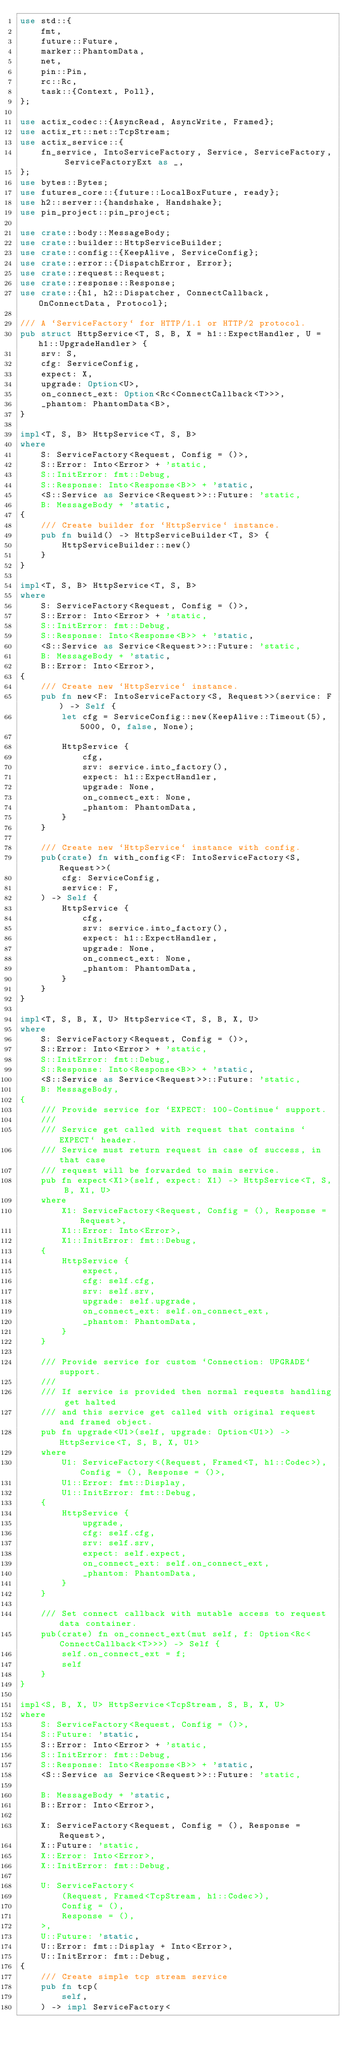Convert code to text. <code><loc_0><loc_0><loc_500><loc_500><_Rust_>use std::{
    fmt,
    future::Future,
    marker::PhantomData,
    net,
    pin::Pin,
    rc::Rc,
    task::{Context, Poll},
};

use actix_codec::{AsyncRead, AsyncWrite, Framed};
use actix_rt::net::TcpStream;
use actix_service::{
    fn_service, IntoServiceFactory, Service, ServiceFactory, ServiceFactoryExt as _,
};
use bytes::Bytes;
use futures_core::{future::LocalBoxFuture, ready};
use h2::server::{handshake, Handshake};
use pin_project::pin_project;

use crate::body::MessageBody;
use crate::builder::HttpServiceBuilder;
use crate::config::{KeepAlive, ServiceConfig};
use crate::error::{DispatchError, Error};
use crate::request::Request;
use crate::response::Response;
use crate::{h1, h2::Dispatcher, ConnectCallback, OnConnectData, Protocol};

/// A `ServiceFactory` for HTTP/1.1 or HTTP/2 protocol.
pub struct HttpService<T, S, B, X = h1::ExpectHandler, U = h1::UpgradeHandler> {
    srv: S,
    cfg: ServiceConfig,
    expect: X,
    upgrade: Option<U>,
    on_connect_ext: Option<Rc<ConnectCallback<T>>>,
    _phantom: PhantomData<B>,
}

impl<T, S, B> HttpService<T, S, B>
where
    S: ServiceFactory<Request, Config = ()>,
    S::Error: Into<Error> + 'static,
    S::InitError: fmt::Debug,
    S::Response: Into<Response<B>> + 'static,
    <S::Service as Service<Request>>::Future: 'static,
    B: MessageBody + 'static,
{
    /// Create builder for `HttpService` instance.
    pub fn build() -> HttpServiceBuilder<T, S> {
        HttpServiceBuilder::new()
    }
}

impl<T, S, B> HttpService<T, S, B>
where
    S: ServiceFactory<Request, Config = ()>,
    S::Error: Into<Error> + 'static,
    S::InitError: fmt::Debug,
    S::Response: Into<Response<B>> + 'static,
    <S::Service as Service<Request>>::Future: 'static,
    B: MessageBody + 'static,
    B::Error: Into<Error>,
{
    /// Create new `HttpService` instance.
    pub fn new<F: IntoServiceFactory<S, Request>>(service: F) -> Self {
        let cfg = ServiceConfig::new(KeepAlive::Timeout(5), 5000, 0, false, None);

        HttpService {
            cfg,
            srv: service.into_factory(),
            expect: h1::ExpectHandler,
            upgrade: None,
            on_connect_ext: None,
            _phantom: PhantomData,
        }
    }

    /// Create new `HttpService` instance with config.
    pub(crate) fn with_config<F: IntoServiceFactory<S, Request>>(
        cfg: ServiceConfig,
        service: F,
    ) -> Self {
        HttpService {
            cfg,
            srv: service.into_factory(),
            expect: h1::ExpectHandler,
            upgrade: None,
            on_connect_ext: None,
            _phantom: PhantomData,
        }
    }
}

impl<T, S, B, X, U> HttpService<T, S, B, X, U>
where
    S: ServiceFactory<Request, Config = ()>,
    S::Error: Into<Error> + 'static,
    S::InitError: fmt::Debug,
    S::Response: Into<Response<B>> + 'static,
    <S::Service as Service<Request>>::Future: 'static,
    B: MessageBody,
{
    /// Provide service for `EXPECT: 100-Continue` support.
    ///
    /// Service get called with request that contains `EXPECT` header.
    /// Service must return request in case of success, in that case
    /// request will be forwarded to main service.
    pub fn expect<X1>(self, expect: X1) -> HttpService<T, S, B, X1, U>
    where
        X1: ServiceFactory<Request, Config = (), Response = Request>,
        X1::Error: Into<Error>,
        X1::InitError: fmt::Debug,
    {
        HttpService {
            expect,
            cfg: self.cfg,
            srv: self.srv,
            upgrade: self.upgrade,
            on_connect_ext: self.on_connect_ext,
            _phantom: PhantomData,
        }
    }

    /// Provide service for custom `Connection: UPGRADE` support.
    ///
    /// If service is provided then normal requests handling get halted
    /// and this service get called with original request and framed object.
    pub fn upgrade<U1>(self, upgrade: Option<U1>) -> HttpService<T, S, B, X, U1>
    where
        U1: ServiceFactory<(Request, Framed<T, h1::Codec>), Config = (), Response = ()>,
        U1::Error: fmt::Display,
        U1::InitError: fmt::Debug,
    {
        HttpService {
            upgrade,
            cfg: self.cfg,
            srv: self.srv,
            expect: self.expect,
            on_connect_ext: self.on_connect_ext,
            _phantom: PhantomData,
        }
    }

    /// Set connect callback with mutable access to request data container.
    pub(crate) fn on_connect_ext(mut self, f: Option<Rc<ConnectCallback<T>>>) -> Self {
        self.on_connect_ext = f;
        self
    }
}

impl<S, B, X, U> HttpService<TcpStream, S, B, X, U>
where
    S: ServiceFactory<Request, Config = ()>,
    S::Future: 'static,
    S::Error: Into<Error> + 'static,
    S::InitError: fmt::Debug,
    S::Response: Into<Response<B>> + 'static,
    <S::Service as Service<Request>>::Future: 'static,

    B: MessageBody + 'static,
    B::Error: Into<Error>,

    X: ServiceFactory<Request, Config = (), Response = Request>,
    X::Future: 'static,
    X::Error: Into<Error>,
    X::InitError: fmt::Debug,

    U: ServiceFactory<
        (Request, Framed<TcpStream, h1::Codec>),
        Config = (),
        Response = (),
    >,
    U::Future: 'static,
    U::Error: fmt::Display + Into<Error>,
    U::InitError: fmt::Debug,
{
    /// Create simple tcp stream service
    pub fn tcp(
        self,
    ) -> impl ServiceFactory<</code> 